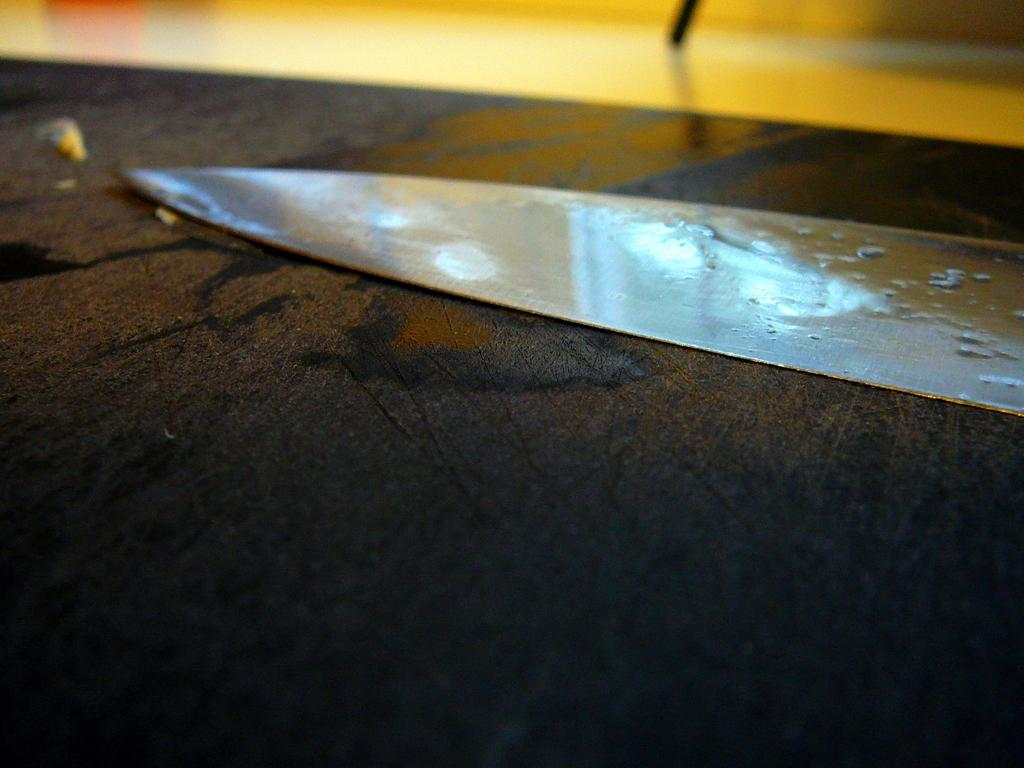What piece of furniture is present in the image? There is a table in the image. What object can be seen on the table? There is a knife on the table. Can you see an owl sitting on the knife in the image? No, there is no owl present in the image. 